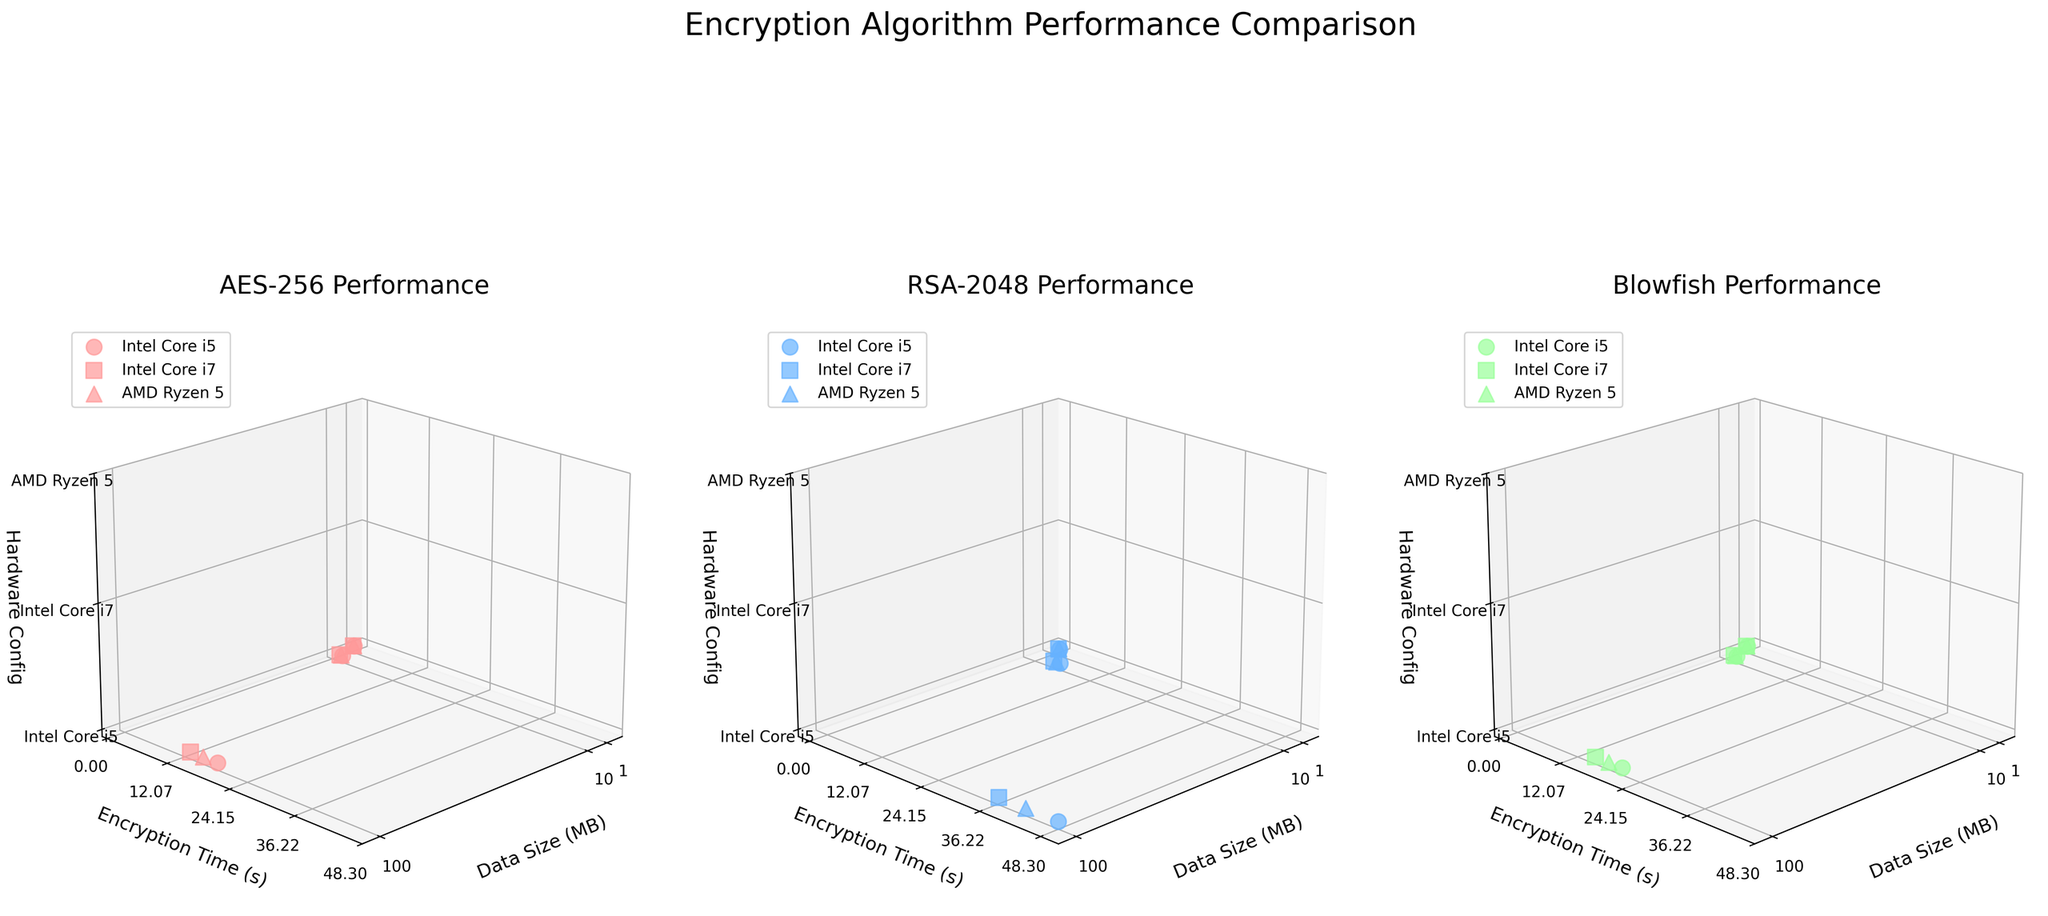What is the title of the entire figure? The title of the entire figure is displayed at the top. It says "Encryption Algorithm Performance Comparison."
Answer: Encryption Algorithm Performance Comparison How many encryption methods are compared in the figure? There are three distinct subplots in the figure, each representing a different encryption method.
Answer: Three What encryption method has the lowest average encryption time for 100 MB of data on Intel Core i7? Referring to the 100 MB data points in each of the three subplots: AES-256 shows around 13.2 seconds, RSA-2048 shows around 36.5 seconds, and Blowfish shows around 15.6 seconds. AES-256 is the lowest.
Answer: AES-256 Which hardware configuration generally performs the worst across different data sizes? For each of the subplots, observe which hardware configuration has the highest encryption times. Intel Core i5 consistently shows higher times compared to Intel Core i7 and AMD Ryzen 5.
Answer: Intel Core i5 What is the encryption time for Blowfish on AMD Ryzen 5 for 10 MB of data? Look within the Blowfish subplot to find the point that corresponds to 10 MB on the x-axis and AMD Ryzen 5. The encryption time is around 2.1 seconds.
Answer: 2.1 seconds Does the RSA-2048 method show the most significant increase in encryption time from 1 MB to 100 MB on any hardware configuration? Observe RSA-2048 encryption times for each hardware: Intel Core i5 goes from 1.2 to 48.3 seconds, Intel Core i7 from 0.9 to 36.5 seconds, and AMD Ryzen 5 from 1.0 to 41.9 seconds. The steepest increase is on Intel Core i5.
Answer: Yes Which encryption method performs more consistently across different hardware configurations and data sizes? Compare the trends of the three subplots. AES-256 and Blowfish show smoother trends across different hardware and data sizes, with Blowfish being slightly more consistent.
Answer: Blowfish Is there any instance where RSA-2048 performs better than AES-256? By comparing corresponding data points for the same data sizes and hardware configurations across the three subplots, observe that AES-256 always has lower encryption times than RSA-2048 for every scenario.
Answer: No 